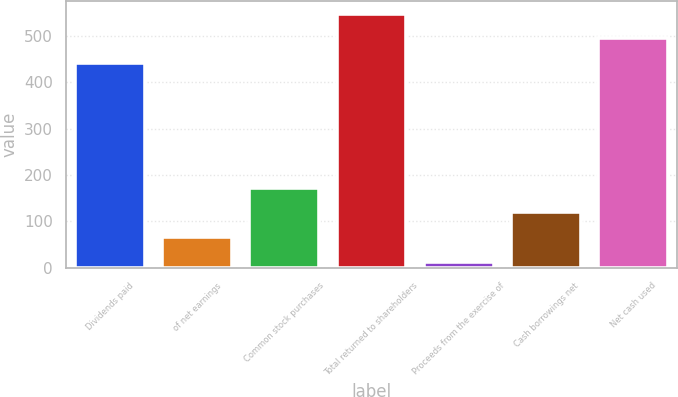<chart> <loc_0><loc_0><loc_500><loc_500><bar_chart><fcel>Dividends paid<fcel>of net earnings<fcel>Common stock purchases<fcel>Total returned to shareholders<fcel>Proceeds from the exercise of<fcel>Cash borrowings net<fcel>Net cash used<nl><fcel>441.9<fcel>66.55<fcel>172.85<fcel>548.2<fcel>13.4<fcel>119.7<fcel>495.05<nl></chart> 